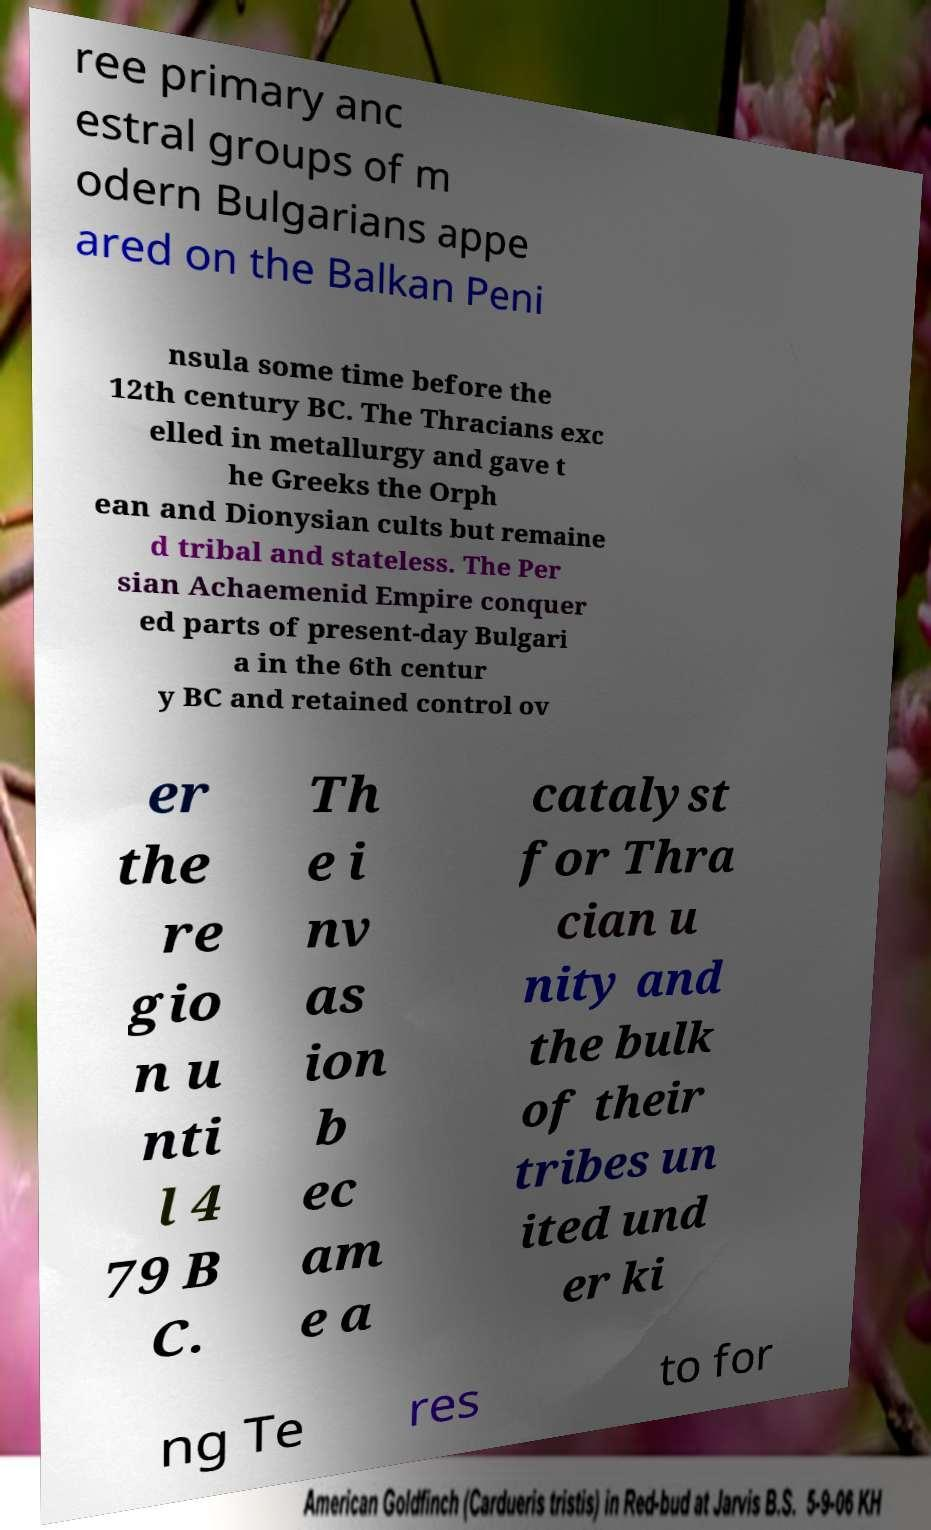Could you assist in decoding the text presented in this image and type it out clearly? ree primary anc estral groups of m odern Bulgarians appe ared on the Balkan Peni nsula some time before the 12th century BC. The Thracians exc elled in metallurgy and gave t he Greeks the Orph ean and Dionysian cults but remaine d tribal and stateless. The Per sian Achaemenid Empire conquer ed parts of present-day Bulgari a in the 6th centur y BC and retained control ov er the re gio n u nti l 4 79 B C. Th e i nv as ion b ec am e a catalyst for Thra cian u nity and the bulk of their tribes un ited und er ki ng Te res to for 